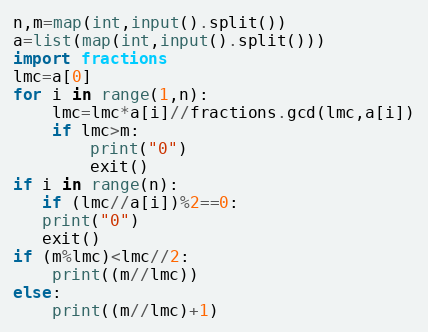Convert code to text. <code><loc_0><loc_0><loc_500><loc_500><_Python_>n,m=map(int,input().split())
a=list(map(int,input().split()))
import fractions
lmc=a[0]
for i in range(1,n):
    lmc=lmc*a[i]//fractions.gcd(lmc,a[i])
    if lmc>m:
        print("0")
        exit()
if i in range(n):
   if (lmc//a[i])%2==0:
   print("0")
   exit()
if (m%lmc)<lmc//2:
    print((m//lmc))
else:
    print((m//lmc)+1)</code> 